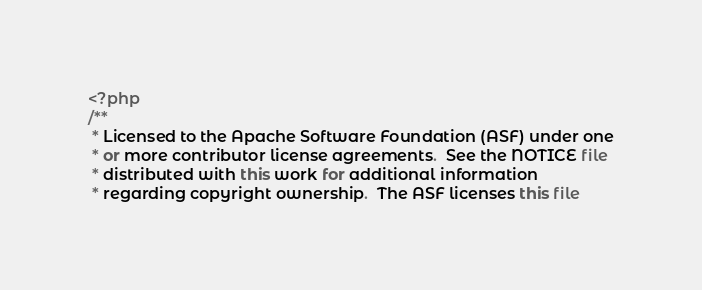Convert code to text. <code><loc_0><loc_0><loc_500><loc_500><_PHP_><?php
/**
 * Licensed to the Apache Software Foundation (ASF) under one
 * or more contributor license agreements.  See the NOTICE file
 * distributed with this work for additional information
 * regarding copyright ownership.  The ASF licenses this file</code> 